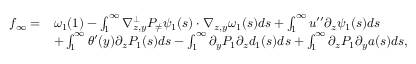<formula> <loc_0><loc_0><loc_500><loc_500>\begin{array} { r } { \begin{array} { r l } { f _ { \infty } = } & { \omega _ { 1 } ( 1 ) - \int _ { 1 } ^ { \infty } \nabla _ { z , y } ^ { \bot } P _ { \neq } \psi _ { 1 } ( s ) \cdot \nabla _ { z , y } \omega _ { 1 } ( s ) d s + \int _ { 1 } ^ { \infty } u ^ { \prime \prime } \partial _ { z } \psi _ { 1 } ( s ) d s } \\ & { + \int _ { 1 } ^ { \infty } \theta ^ { \prime } ( y ) \partial _ { z } P _ { 1 } ( s ) d s - \int _ { 1 } ^ { \infty } \partial _ { y } P _ { 1 } \partial _ { z } d _ { 1 } ( s ) d s + \int _ { 1 } ^ { \infty } \partial _ { z } P _ { 1 } \partial _ { y } a ( s ) d s , } \end{array} } \end{array}</formula> 